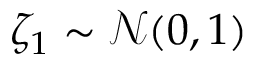<formula> <loc_0><loc_0><loc_500><loc_500>\zeta _ { 1 } \sim \mathcal { N } ( 0 , 1 )</formula> 